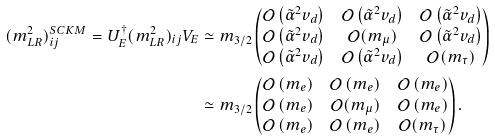<formula> <loc_0><loc_0><loc_500><loc_500>( m _ { L R } ^ { 2 } ) ^ { S C K M } _ { i j } = U _ { E } ^ { \dagger } ( m _ { L R } ^ { 2 } ) _ { i j } V _ { E } & \simeq m _ { 3 / 2 } \begin{pmatrix} \mathcal { O } \left ( \tilde { \alpha } ^ { 2 } v _ { d } \right ) & \mathcal { O } \left ( \tilde { \alpha } ^ { 2 } v _ { d } \right ) & \mathcal { O } \left ( \tilde { \alpha } ^ { 2 } v _ { d } \right ) \\ \mathcal { O } \left ( \tilde { \alpha } ^ { 2 } v _ { d } \right ) & \mathcal { O } ( m _ { \mu } ) & \mathcal { O } \left ( \tilde { \alpha } ^ { 2 } v _ { d } \right ) \\ \mathcal { O } \left ( \tilde { \alpha } ^ { 2 } v _ { d } \right ) & \mathcal { O } \left ( \tilde { \alpha } ^ { 2 } v _ { d } \right ) & \mathcal { O } ( m _ { \tau } ) \end{pmatrix} \\ & \simeq m _ { 3 / 2 } \begin{pmatrix} \mathcal { O } \left ( m _ { e } \right ) & \mathcal { O } \left ( m _ { e } \right ) & \mathcal { O } \left ( m _ { e } \right ) \\ \mathcal { O } \left ( m _ { e } \right ) & \mathcal { O } ( m _ { \mu } ) & \mathcal { O } \left ( m _ { e } \right ) \\ \mathcal { O } \left ( m _ { e } \right ) & \mathcal { O } \left ( m _ { e } \right ) & \mathcal { O } ( m _ { \tau } ) \end{pmatrix} .</formula> 